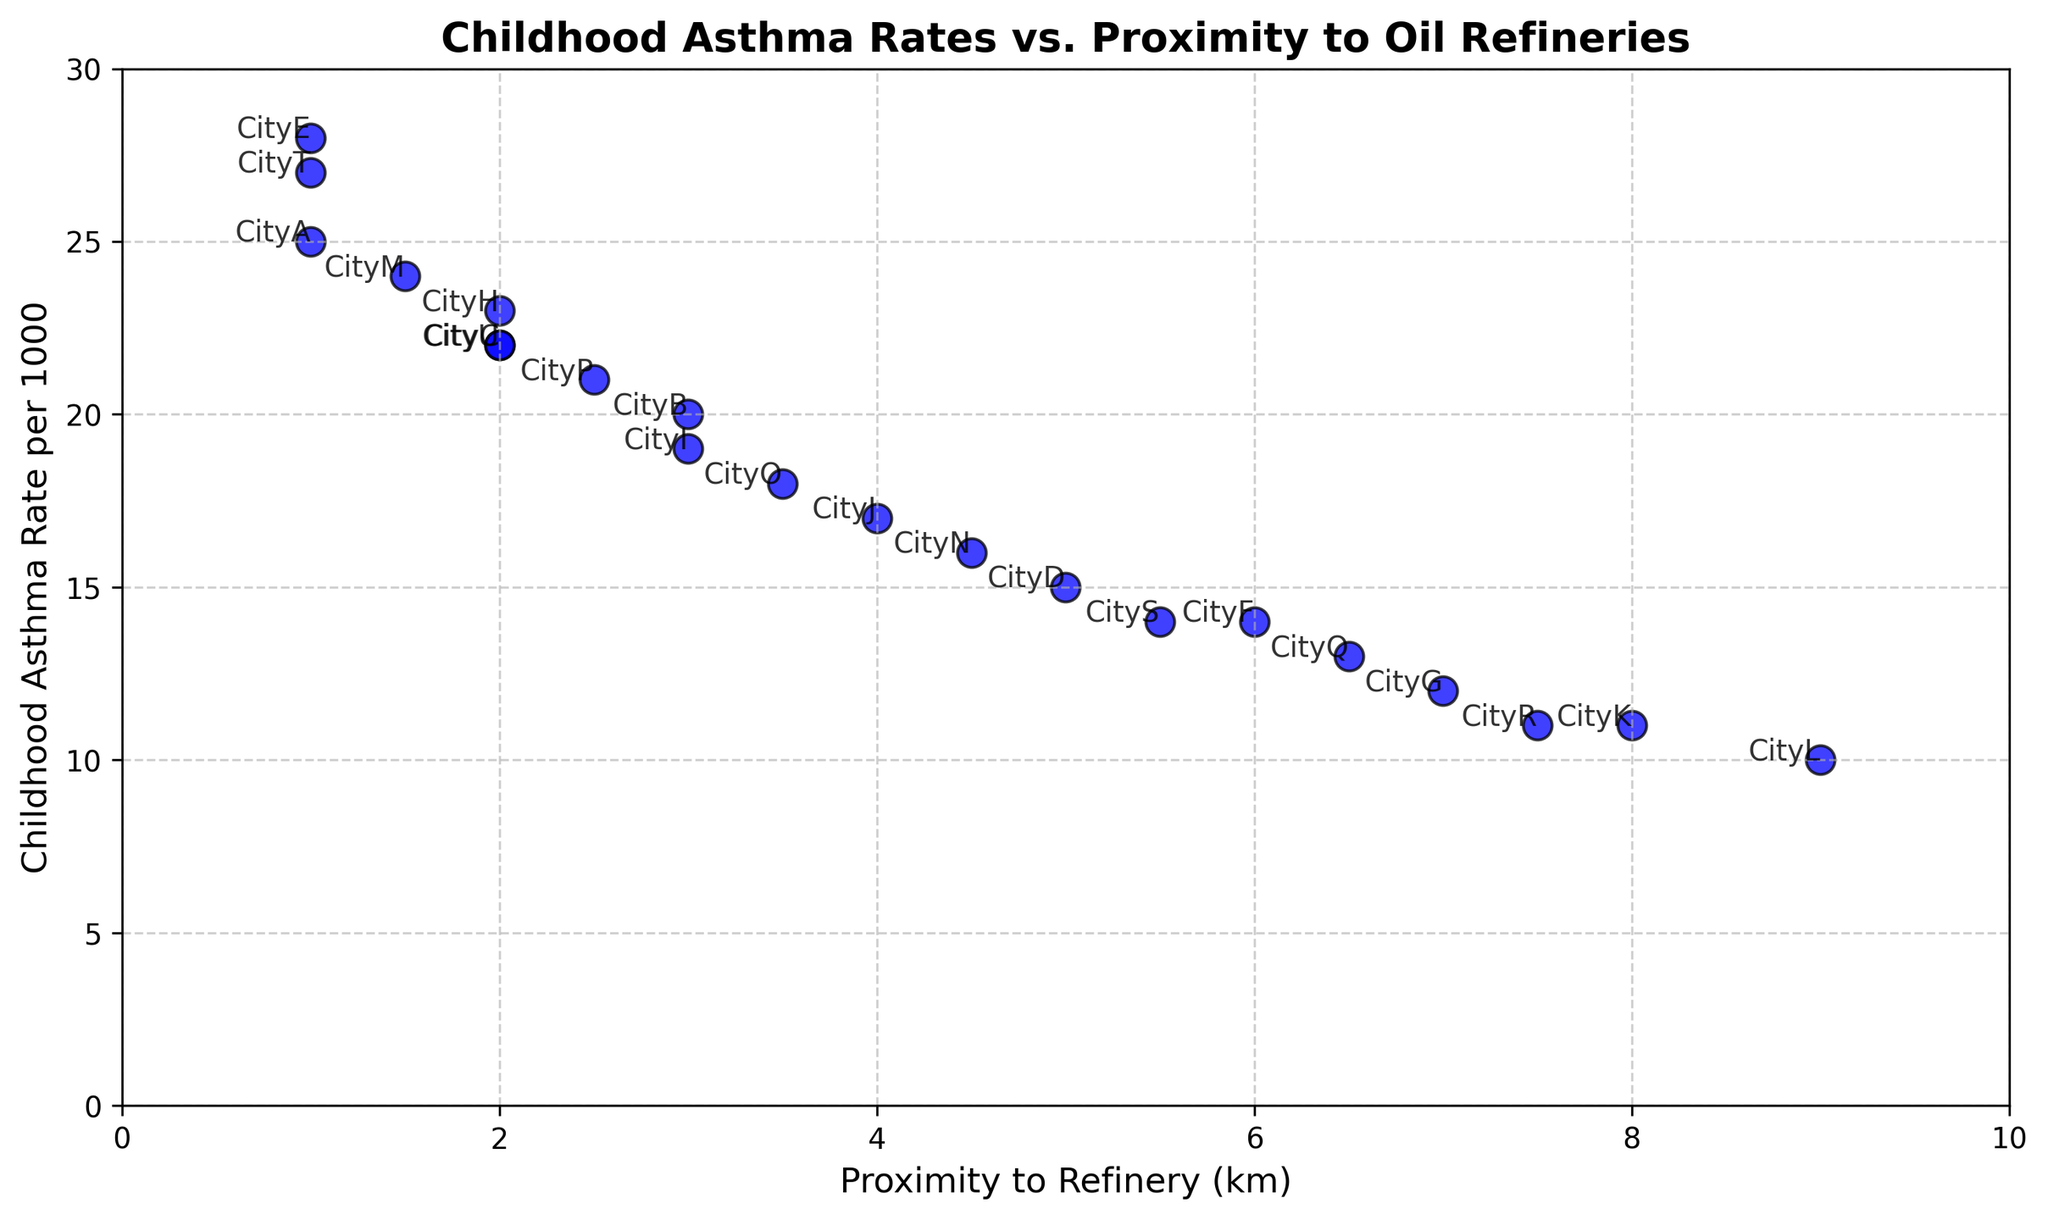Which city has the highest childhood asthma rate, and what is that rate? By looking at the scatter plot, identify the city with the highest position on the y-axis, which represents the asthma rate.
Answer: CityE, 28 Which city is the farthest from an oil refinery, and what is the childhood asthma rate for that city? Look for the point with the highest x-axis value, which represents the proximity to the refinery, and note its corresponding y-axis value for asthma rate.
Answer: CityL, 10 What is the average childhood asthma rate for cities located within 2 km of an oil refinery? Identify all cities within 2 km of the refinery (CityA, CityE, CityT, CityM), sum their asthma rates (25 + 28 + 27 + 24 = 104), and divide by the number of such cities (4).
Answer: 26 Which city has the lowest childhood asthma rate among those located within 4 km of an oil refinery? Filter out the cities within 4 km (Cities A, B, C, E, H, I, M, O, P, U) and identify the one with the lowest y-axis value (asthma rate).
Answer: CityI, 19 Is there a general trend or correlation between proximity to oil refineries and childhood asthma rates? Observe the overall distribution of points in the scatter plot to see if there is an upward or downward trend as the x-axis values increase.
Answer: Yes, closer proximity tends to higher asthma rates Which city has a childhood asthma rate of exactly 22 per 1000, and how far is it from the refinery? Locate the point corresponding to 22 on the y-axis and identify its x-axis value.
Answer: CityU, 2 km What is the median childhood asthma rate for all the cities shown? List all asthma rates in increasing order and find the middle value. Since there are 20 cities, the median is the average of the 10th and 11th values: (21 + 22) / 2.
Answer: 21.5 Among the cities located more than 5 km from a refinery, which one has the highest childhood asthma rate? Filter out cities located beyond 5 km (Cities F, G, K, Q, R, S), and identify the one with the highest y-axis value.
Answer: CityS, 14 How many cities have a childhood asthma rate greater than 20 per 1000? Count the number of points that lie above the y-axis value of 20.
Answer: 8 